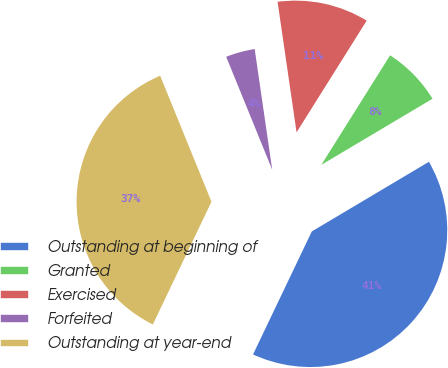Convert chart. <chart><loc_0><loc_0><loc_500><loc_500><pie_chart><fcel>Outstanding at beginning of<fcel>Granted<fcel>Exercised<fcel>Forfeited<fcel>Outstanding at year-end<nl><fcel>40.63%<fcel>7.54%<fcel>11.22%<fcel>3.86%<fcel>36.75%<nl></chart> 